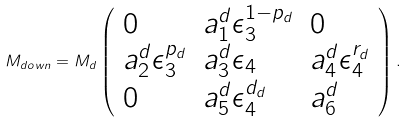<formula> <loc_0><loc_0><loc_500><loc_500>M _ { d o w n } = M _ { d } \left ( \begin{array} { l l l } { 0 } & { { a _ { 1 } ^ { d } \epsilon _ { 3 } ^ { 1 - p _ { d } } } } & { 0 } \\ { { a _ { 2 } ^ { d } \epsilon _ { 3 } ^ { p _ { d } } } } & { { a _ { 3 } ^ { d } \epsilon _ { 4 } } } & { { a _ { 4 } ^ { d } \epsilon _ { 4 } ^ { r _ { d } } } } \\ { 0 } & { { a _ { 5 } ^ { d } \epsilon _ { 4 } ^ { d _ { d } } } } & { { a _ { 6 } ^ { d } } } \end{array} \right ) .</formula> 